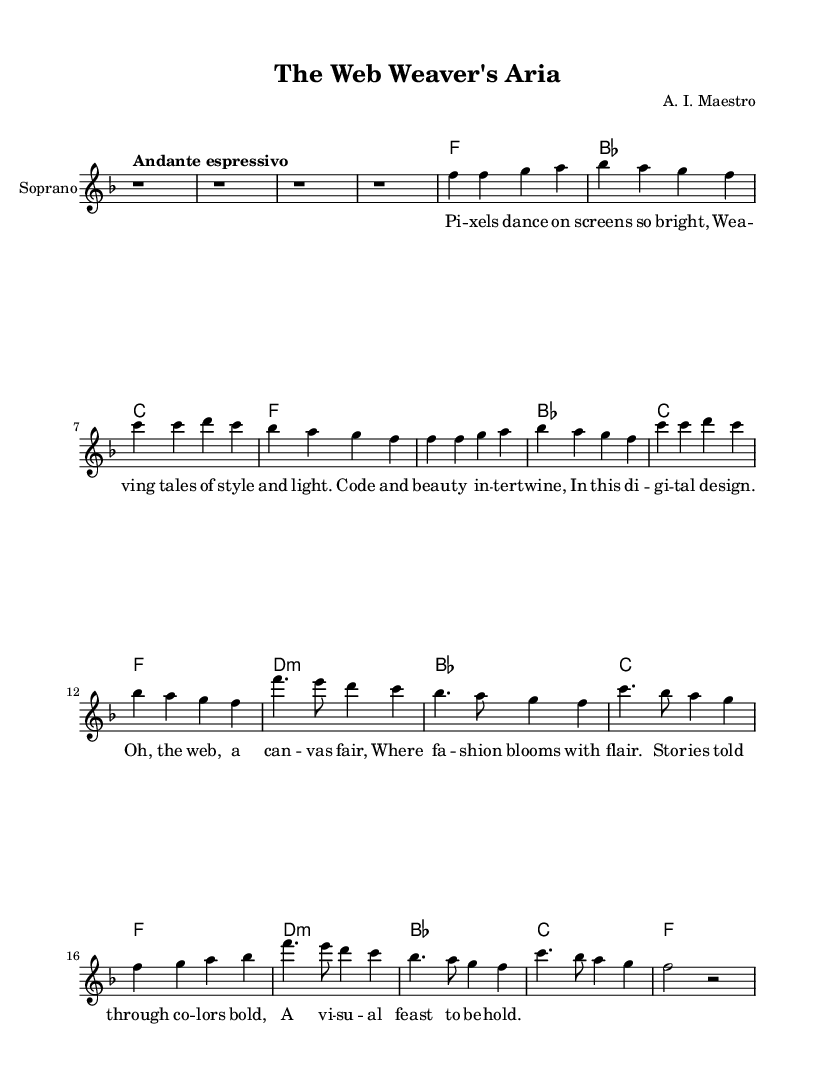What is the key signature of this music? The key signature is F major, which has one flat (B flat).
Answer: F major What is the time signature of this piece? The time signature is 4/4, meaning there are four beats per measure.
Answer: 4/4 What is the tempo marking for this piece? The tempo marking indicates "Andante espressivo," which suggests a moderately slow and expressive style.
Answer: Andante espressivo How many measures are in the introduction? The introduction consists of four measures, as indicated by the notation before any melodic or harmonic content begins.
Answer: 4 What is the name of the composer? The composer's name is A. I. Maestro, which is indicated in the header of the sheet music.
Answer: A. I. Maestro In the chorus, what harmonic chord is used first? The first chord in the chorus is D minor, as observed in the chord line corresponding to the melody.
Answer: D minor What recurring theme is depicted in the lyrics? The lyrics celebrate digital artistry and visual storytelling, highlighting themes of beauty and design in the context of the web.
Answer: Digital artistry 